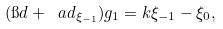Convert formula to latex. <formula><loc_0><loc_0><loc_500><loc_500>( \i d + \ a d _ { \xi _ { - 1 } } ) g _ { 1 } = k \xi _ { - 1 } - \xi _ { 0 } ,</formula> 